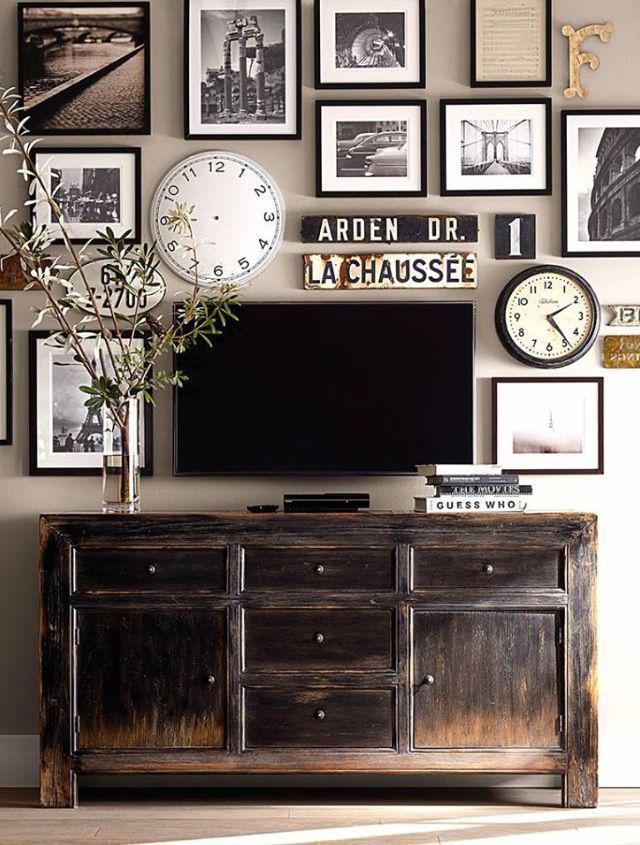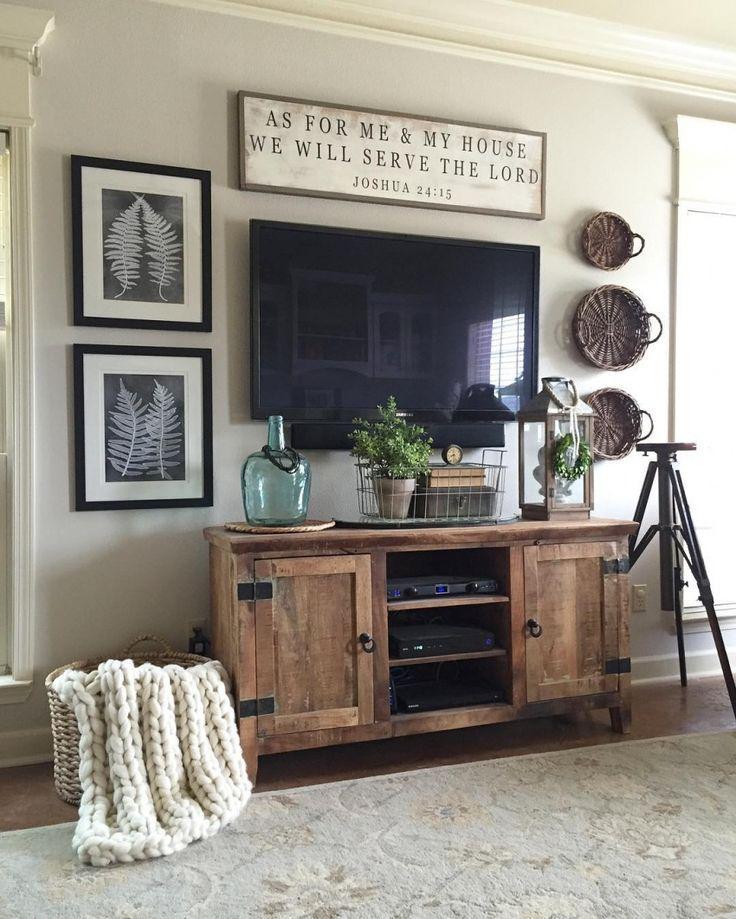The first image is the image on the left, the second image is the image on the right. Examine the images to the left and right. Is the description "there is at least one clock on the wall behind the tv" accurate? Answer yes or no. Yes. 